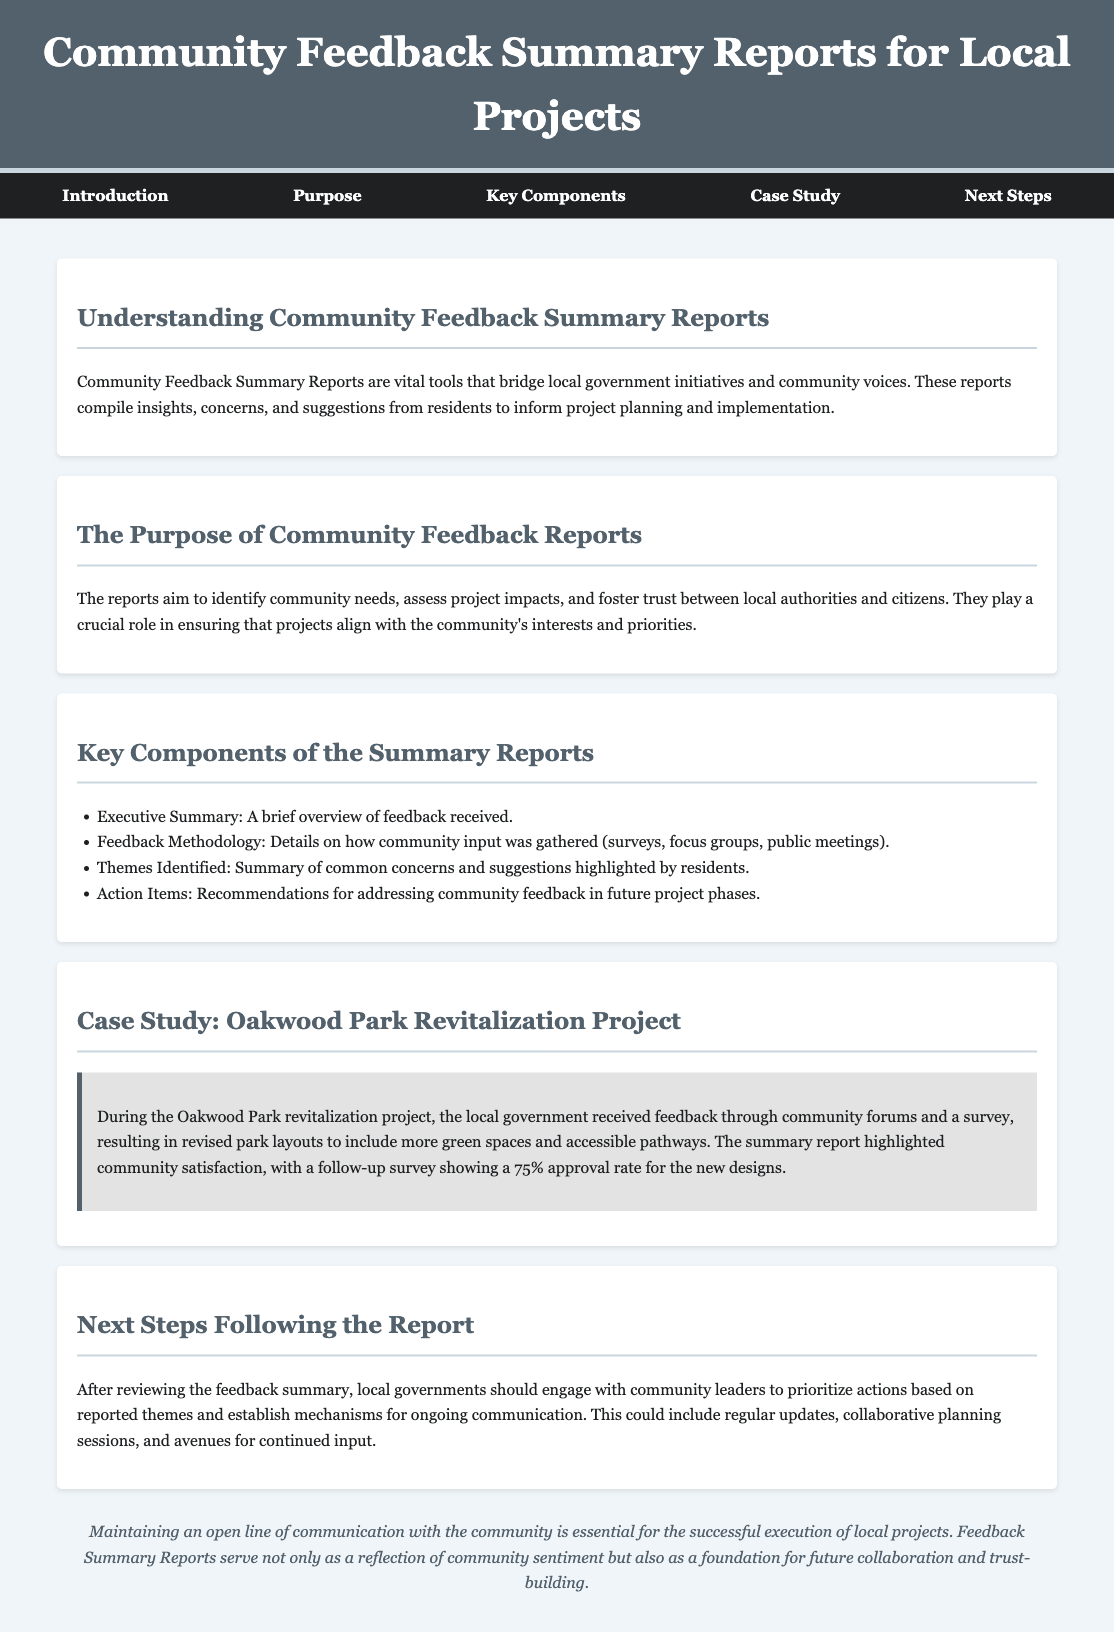what is the title of the document? The title is located in the header section of the document and summarizes the content it covers.
Answer: Community Feedback Summary Reports for Local Projects what is the purpose of the community feedback reports? The purpose is outlined in a dedicated section, highlighting its significance in community engagement and project alignment.
Answer: Identify community needs, assess project impacts, and foster trust how many components are listed in the summary reports? The number of key components can be counted in the section that describes them in detail.
Answer: Four what is one method used to gather feedback? The methodology section provides different ways of obtaining input from the residents.
Answer: Surveys what percentage of approval was shown for the new park designs? This information is found within the case study, summarizing community feedback and satisfaction levels.
Answer: 75% what should local governments do after reviewing the feedback summary? This is explained in the next steps section where future actions are proposed based on the report.
Answer: Engage with community leaders which project is used as a case study in the document? The case study section mentions a specific project to illustrate the feedback process.
Answer: Oakwood Park Revitalization Project what type of summary is provided at the beginning of the reports? The initial part of the report indicates the overview of feedback received.
Answer: Executive Summary 